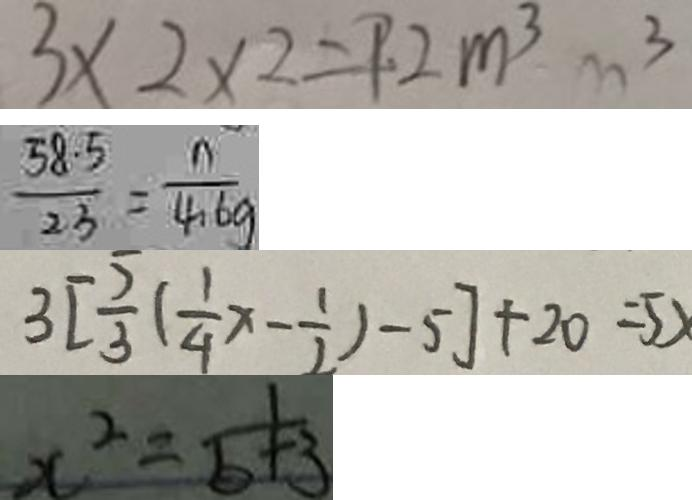Convert formula to latex. <formula><loc_0><loc_0><loc_500><loc_500>3 \times 2 \times 2 = 9 2 m ^ { 3 } m ^ { 3 } 
 \frac { 5 8 . 5 } { 2 3 } = \frac { n } { 4 . 6 g } 
 3 [ \frac { 5 } { 3 } ( \frac { 1 } { 4 } x - \frac { 1 } { 2 } ) - 5 ] + 2 0 = 5 x 
 x ^ { 2 } = \frac { 1 } { b + 3 }</formula> 